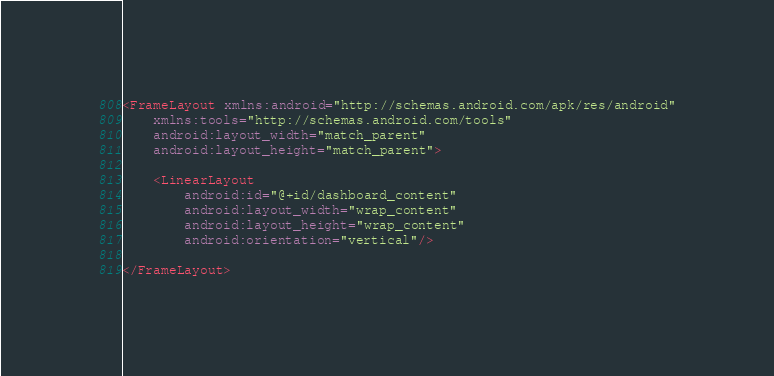Convert code to text. <code><loc_0><loc_0><loc_500><loc_500><_XML_><FrameLayout xmlns:android="http://schemas.android.com/apk/res/android"
    xmlns:tools="http://schemas.android.com/tools"
    android:layout_width="match_parent"
    android:layout_height="match_parent">

    <LinearLayout
        android:id="@+id/dashboard_content"
        android:layout_width="wrap_content"
        android:layout_height="wrap_content"
        android:orientation="vertical"/>

</FrameLayout></code> 